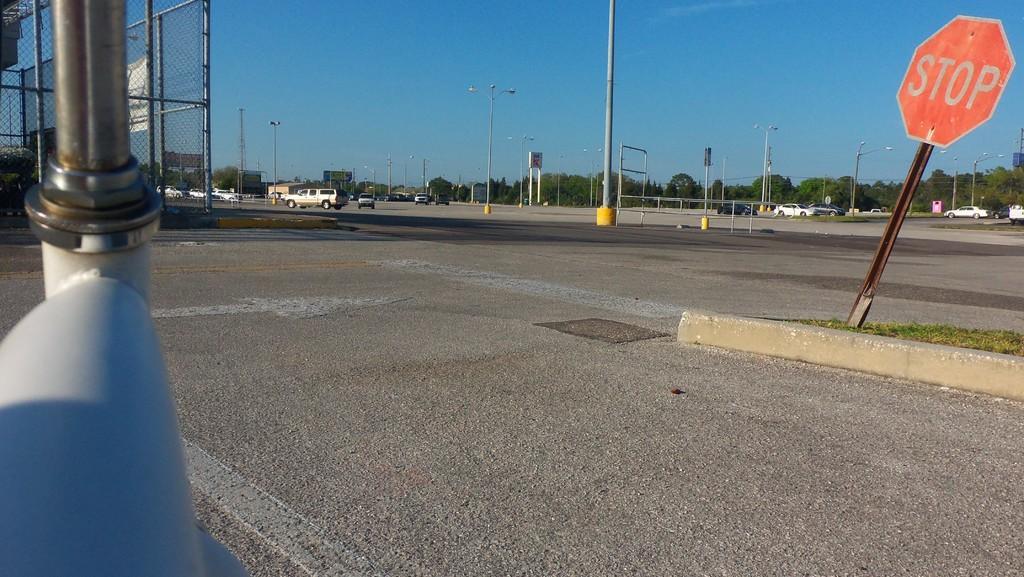Can you describe this image briefly? In this image we can see roads. Also there are vehicles. And there are poles. And there is a sign board with a pole. And there are light poles. On the left side there is a mesh wall with poles. In the background there is sky. Also there are trees. 